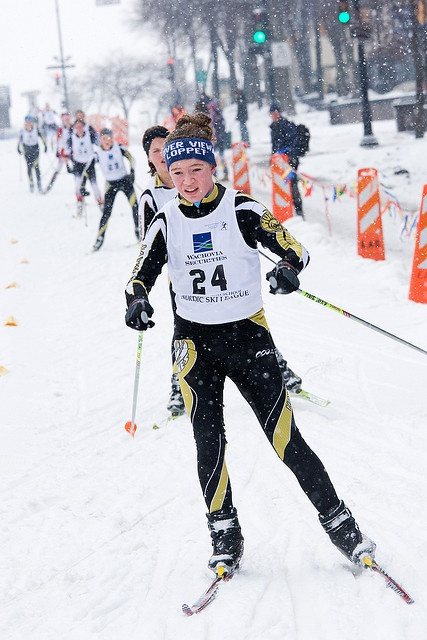Describe the objects in this image and their specific colors. I can see people in white, black, lavender, gray, and navy tones, people in white, lavender, darkgray, gray, and black tones, people in white, navy, gray, black, and darkgray tones, people in white, lavender, black, lightpink, and darkgray tones, and people in white, lavender, darkgray, and gray tones in this image. 